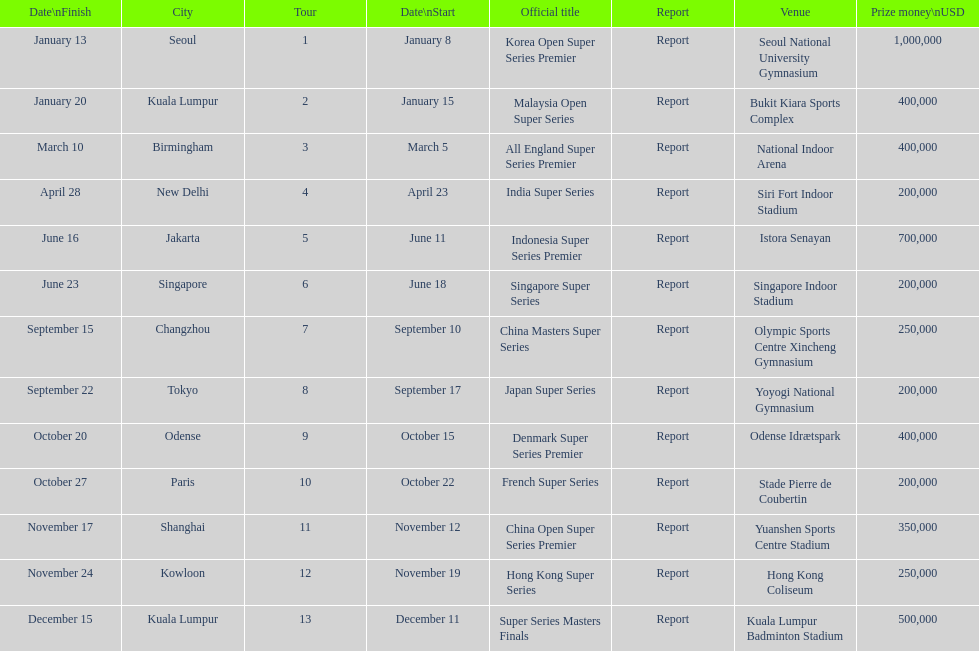Which series has the highest prize payout? Korea Open Super Series Premier. 